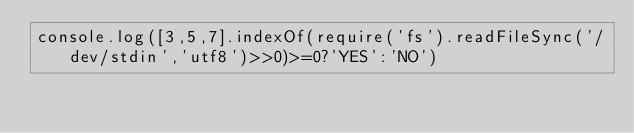<code> <loc_0><loc_0><loc_500><loc_500><_JavaScript_>console.log([3,5,7].indexOf(require('fs').readFileSync('/dev/stdin','utf8')>>0)>=0?'YES':'NO')</code> 